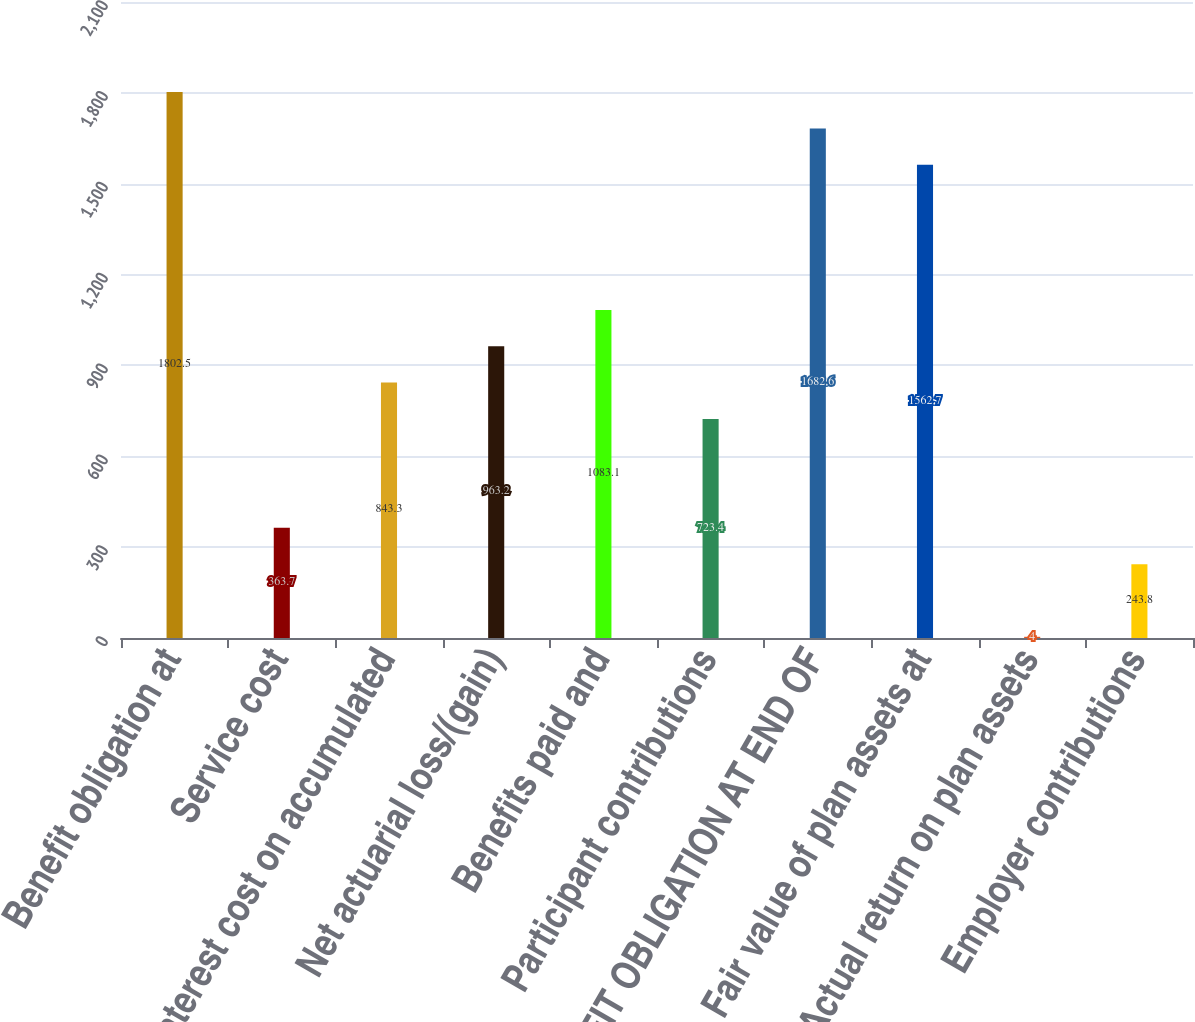Convert chart to OTSL. <chart><loc_0><loc_0><loc_500><loc_500><bar_chart><fcel>Benefit obligation at<fcel>Service cost<fcel>Interest cost on accumulated<fcel>Net actuarial loss/(gain)<fcel>Benefits paid and<fcel>Participant contributions<fcel>BENEFIT OBLIGATION AT END OF<fcel>Fair value of plan assets at<fcel>Actual return on plan assets<fcel>Employer contributions<nl><fcel>1802.5<fcel>363.7<fcel>843.3<fcel>963.2<fcel>1083.1<fcel>723.4<fcel>1682.6<fcel>1562.7<fcel>4<fcel>243.8<nl></chart> 